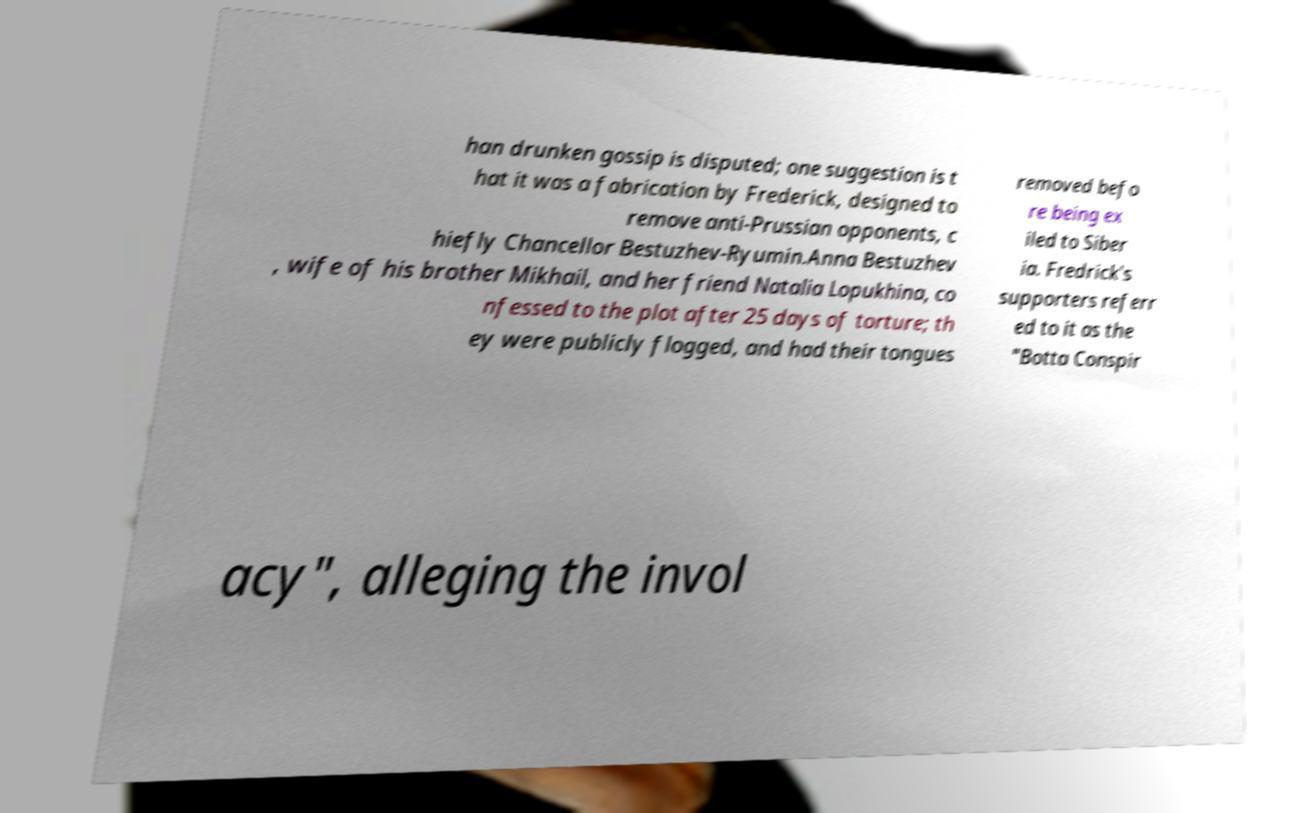I need the written content from this picture converted into text. Can you do that? han drunken gossip is disputed; one suggestion is t hat it was a fabrication by Frederick, designed to remove anti-Prussian opponents, c hiefly Chancellor Bestuzhev-Ryumin.Anna Bestuzhev , wife of his brother Mikhail, and her friend Natalia Lopukhina, co nfessed to the plot after 25 days of torture; th ey were publicly flogged, and had their tongues removed befo re being ex iled to Siber ia. Fredrick's supporters referr ed to it as the "Botta Conspir acy", alleging the invol 